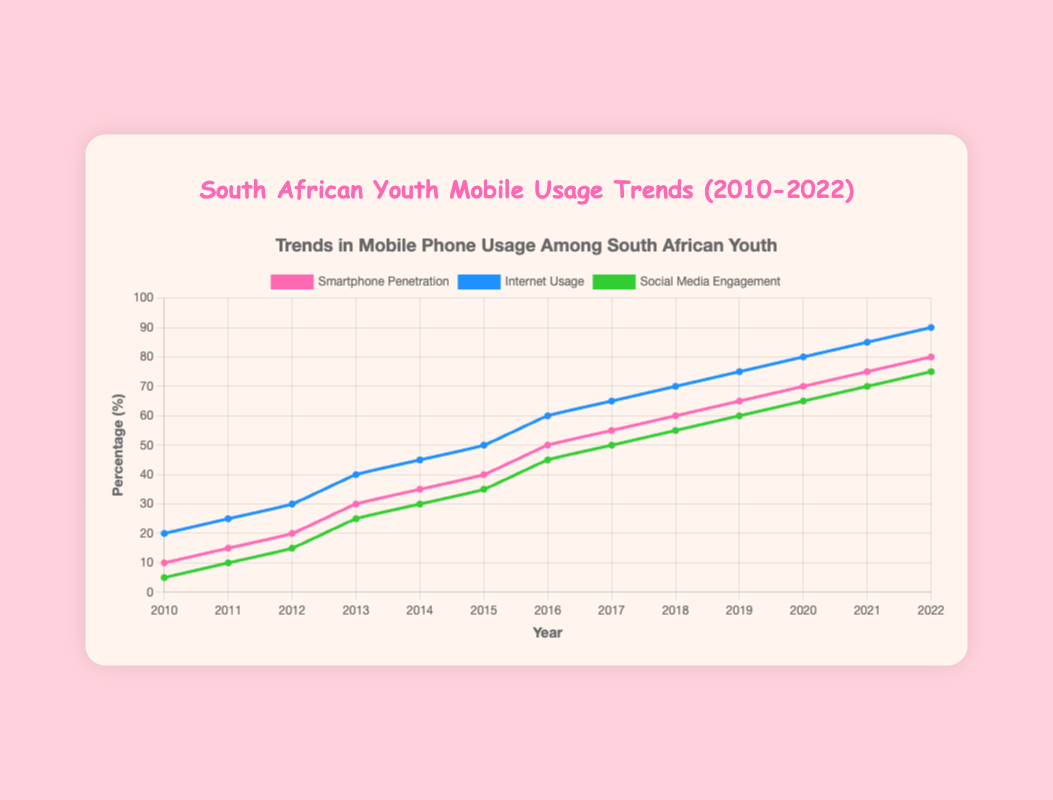What year saw smartphone penetration at 50% in South African youth? Find the point where the "Smartphone Penetration" line hits 50%. It happens in the year 2016.
Answer: 2016 By how much did social media engagement percentage increase from 2011 to 2015? Look at the "Social Media Engagement" line and find the points for 2011 and 2015, which are 10% and 35% respectively. Subtract the 2011 value from the 2015 value (35% - 10% = 25%)
Answer: 25% Which category saw the greatest increase between 2010 and 2022? Compare the total increases for "Smartphone Penetration," "Internet Usage," and "Social Media Engagement" from 2010 to 2022 by looking at the differences between their start and end points. "Internet Usage" went from 20% to 90% (70% increase), "Smartphone Penetration" increased by 70% (10% to 80%), and "Social Media Engagement" increased by 70% (5% to 75%)
Answer: Tie What was the difference between internet usage and smartphone penetration in 2022? Look at the values for both "Internet Usage" and "Smartphone Penetration" in 2022. "Internet Usage" is 90% and "Smartphone Penetration" is 80%. Subtract 80% from 90% (90% - 80% = 10%)
Answer: 10% In which year did social media engagement reach halfway (i.e., 37.5%) between its initial (5%) and final (75%) values? Calculate the midpoint of the initial and final values of "Social Media Engagement," which is (5 + 75) / 2 = 37.5%. Find the year in the line chart where this value is reached. It's in 2015.
Answer: 2015 Between 2013 and 2017, how many years saw an increase in smartphone penetration? Analyze the "Smartphone Penetration" line between 2013 and 2017, noting that it increased every year: from 30% in 2013 to 55% in 2017. This gives us 2014, 2015, 2016, and 2017, totaling 4 years.
Answer: 4 When did South African youth’s internet usage first surpass 50%? Check the "Internet Usage" line and find the first year where it crosses 50%. This happens in 2016.
Answer: 2016 How many years did it take for social media engagement to increase from 5% to 50%? Identify the years when "Social Media Engagement" was 5% (2010) and 50% (2017), then calculate the difference between these years (2017 - 2010 = 7 years)
Answer: 7 What are the colors representing the different categories in the chart? Look at the lines' colors in the chart. "Smartphone Penetration" is pink, "Internet Usage" is blue, and "Social Media Engagement" is green.
Answer: Pink, Blue, Green 